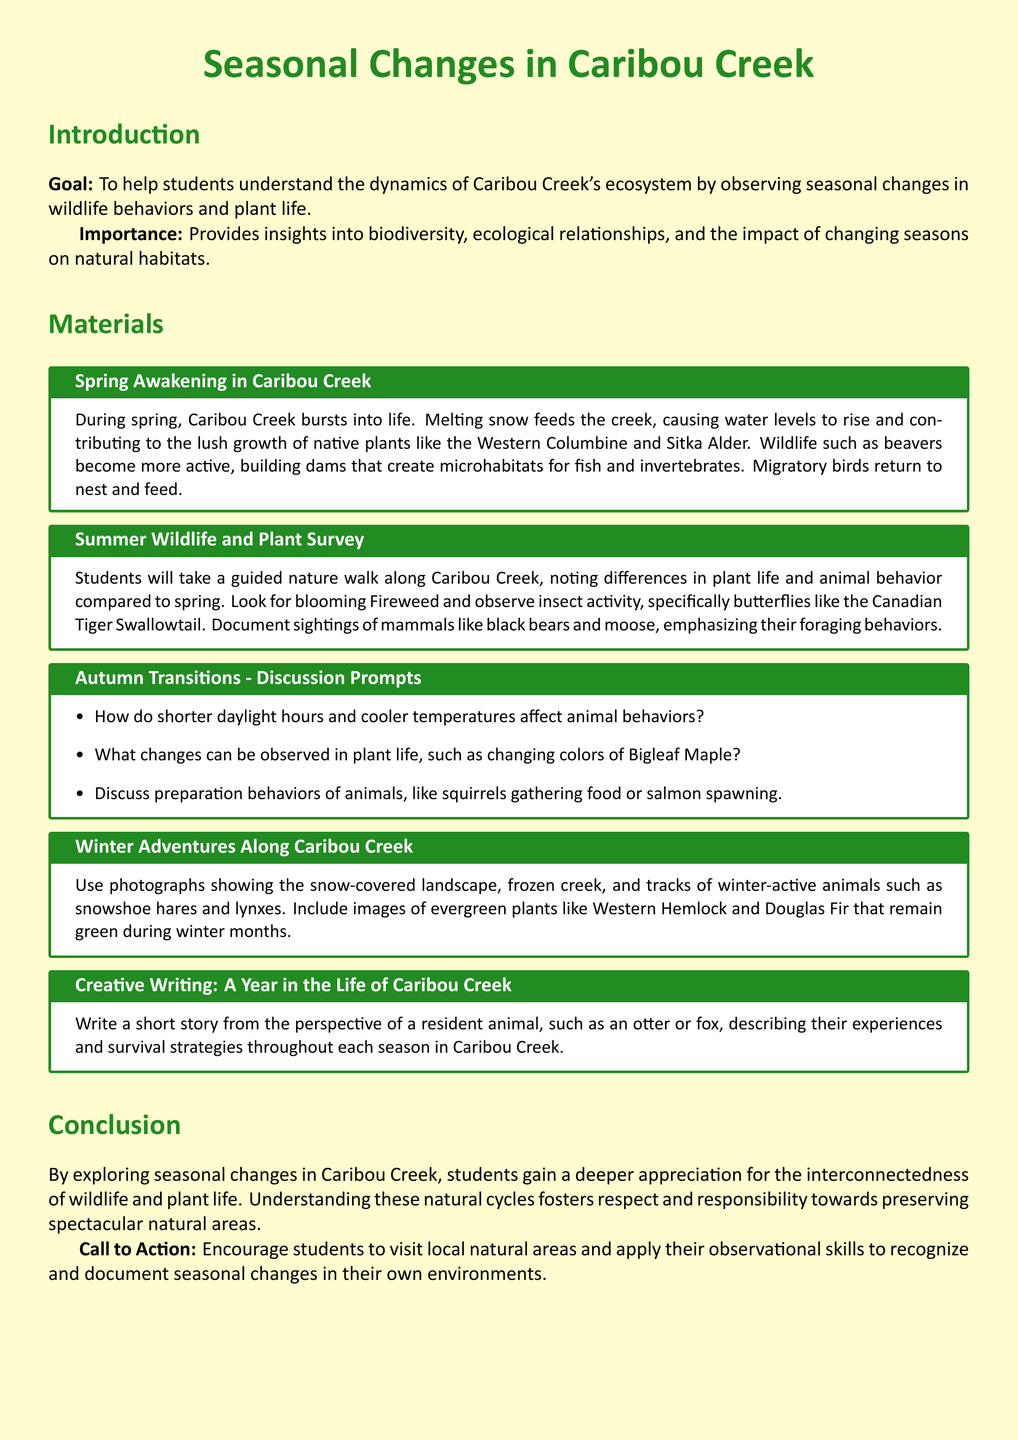what is the main goal of the lesson plan? The main goal is to help students understand the dynamics of Caribou Creek's ecosystem by observing seasonal changes in wildlife behaviors and plant life.
Answer: understanding dynamics which plant is highlighted in spring? The plant highlighted in spring is the Western Columbine.
Answer: Western Columbine what does the guided nature walk in summer focus on documenting? The guided nature walk focuses on documenting differences in plant life and animal behavior compared to spring.
Answer: differences in plant life and animal behavior name one animal mentioned that is active during autumn. One animal mentioned that is active during autumn is the squirrel.
Answer: squirrel what writing activity is suggested in the lesson plan? The suggested writing activity is to write a short story from the perspective of a resident animal.
Answer: short story how does the conclusion summarize the lesson plan? The conclusion emphasizes gaining a deeper appreciation for the interconnectedness of wildlife and plant life.
Answer: deeper appreciation which season involves a photograph of snow-covered landscapes? The season that involves a photograph of snow-covered landscapes is winter.
Answer: winter what is the call to action for students? The call to action is to visit local natural areas and apply their observational skills.
Answer: visit local natural areas 